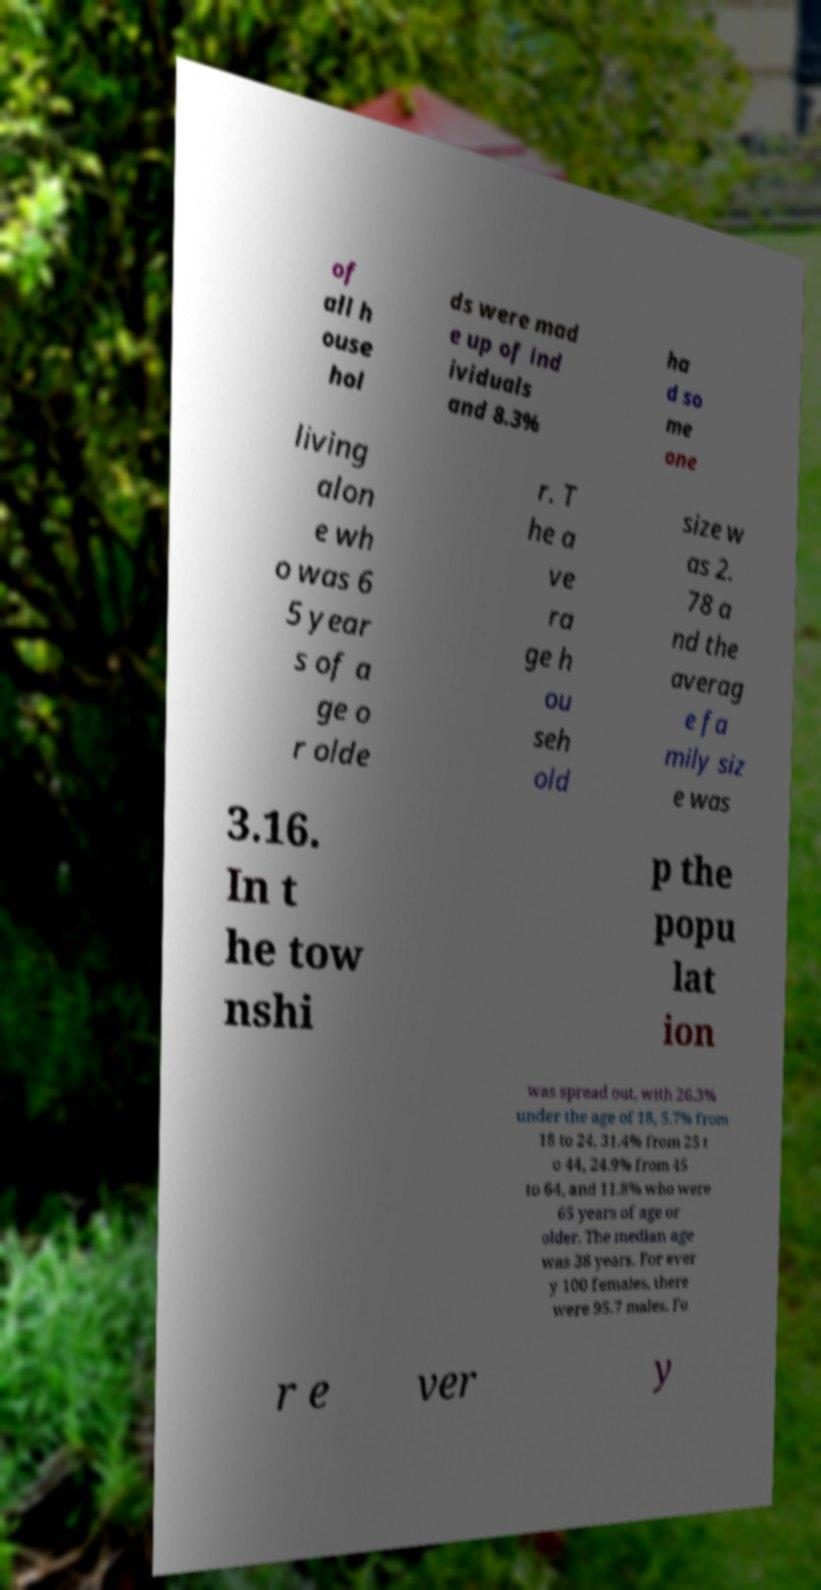For documentation purposes, I need the text within this image transcribed. Could you provide that? of all h ouse hol ds were mad e up of ind ividuals and 8.3% ha d so me one living alon e wh o was 6 5 year s of a ge o r olde r. T he a ve ra ge h ou seh old size w as 2. 78 a nd the averag e fa mily siz e was 3.16. In t he tow nshi p the popu lat ion was spread out, with 26.3% under the age of 18, 5.7% from 18 to 24, 31.4% from 25 t o 44, 24.9% from 45 to 64, and 11.8% who were 65 years of age or older. The median age was 38 years. For ever y 100 females, there were 95.7 males. Fo r e ver y 